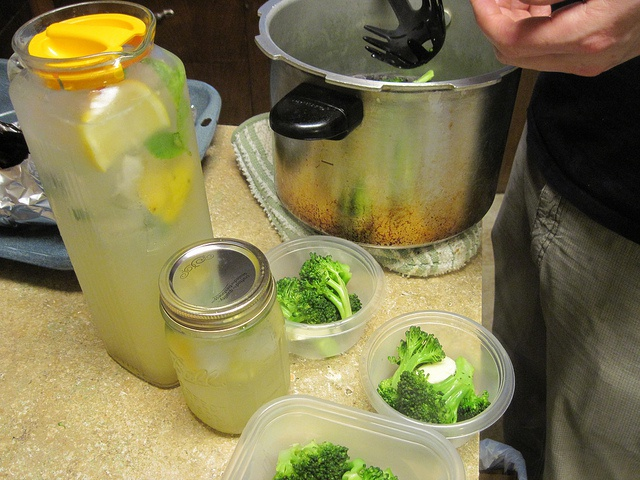Describe the objects in this image and their specific colors. I can see dining table in black, tan, khaki, and darkgray tones, people in black, gray, and maroon tones, bottle in black, olive, gold, and orange tones, bottle in black, tan, olive, and gray tones, and bowl in black, khaki, darkgray, olive, and lightgreen tones in this image. 